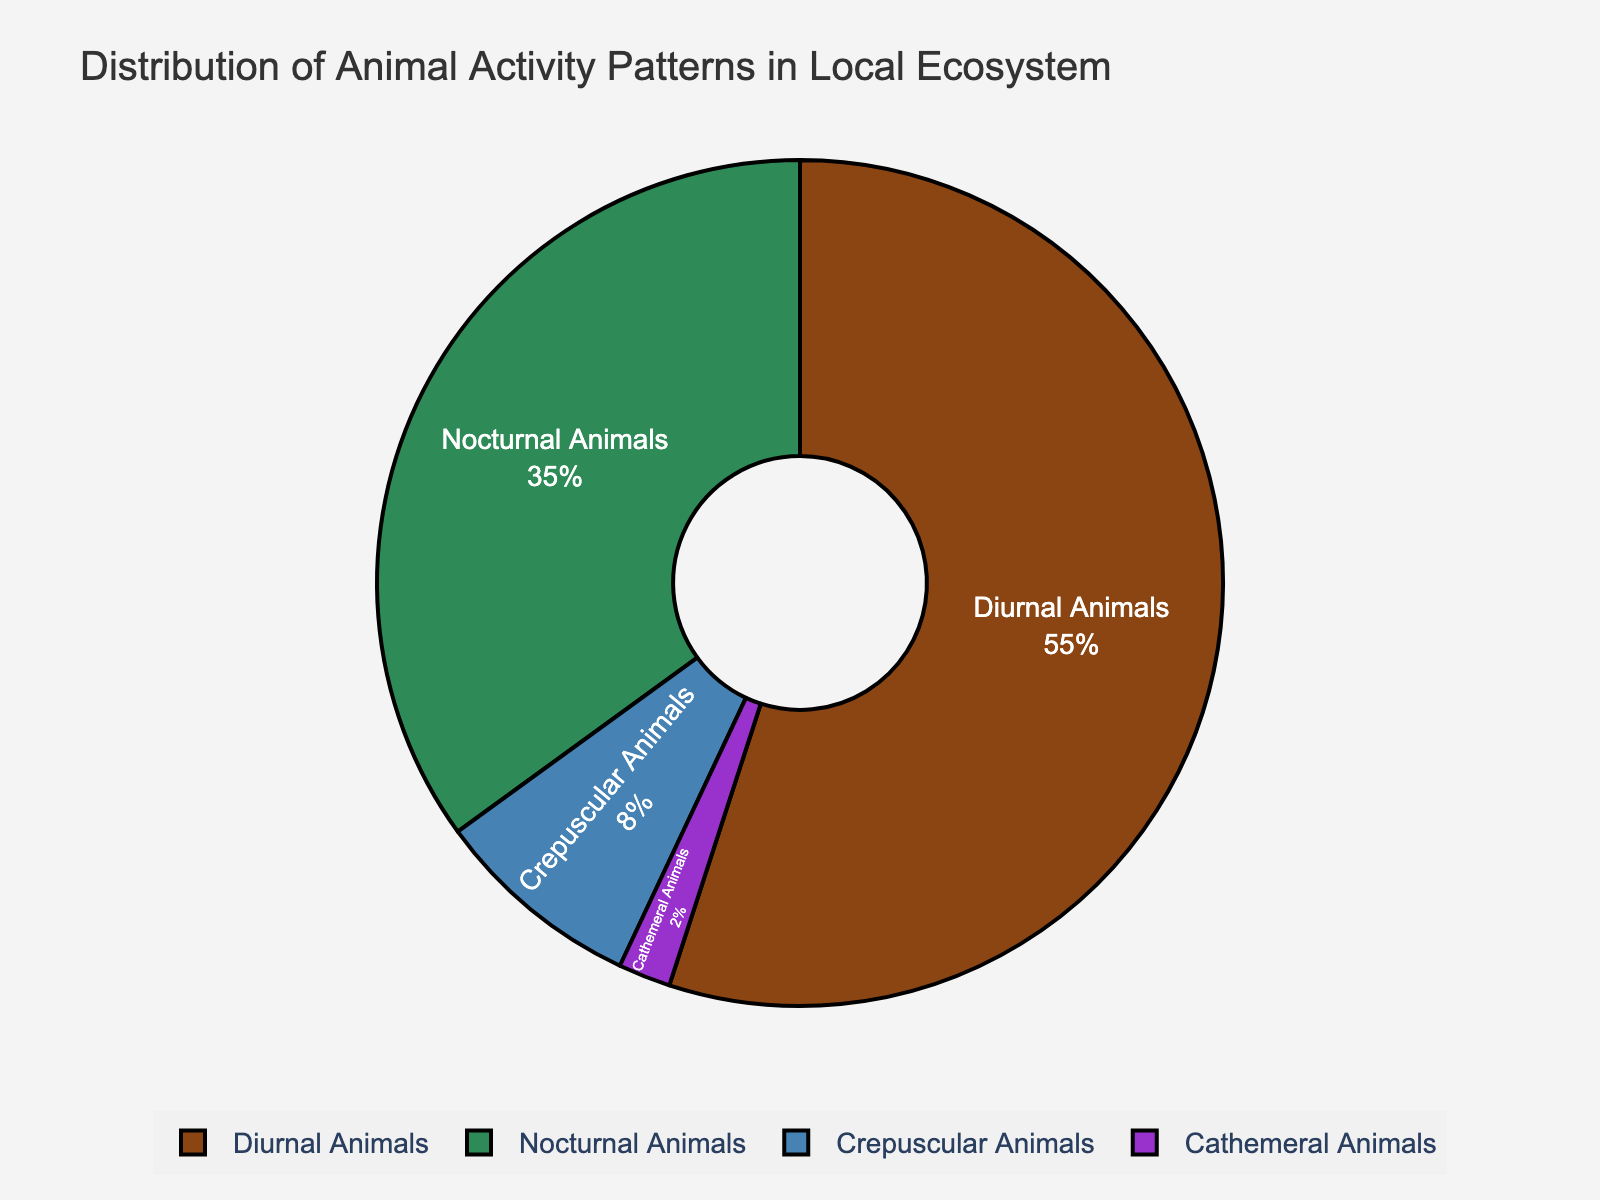What proportion of animals in the local ecosystem are active at twilight? According to the legend, the "Crepuscular Animals" category represents 8% of the overall proportion. Therefore, 8% of animals in the local ecosystem are active during twilight.
Answer: 8% Which category has the highest proportion of animals? By examining the pie chart, the segment representing "Diurnal Animals" is the largest, accounting for 55% of the total proportion, which is the highest.
Answer: Diurnal Animals Are there more nocturnal or crepuscular animals in the local ecosystem? Comparing the two segments visually, "Nocturnal Animals" accounts for 35% while "Crepuscular Animals" accounts for 8%. Therefore, there are more nocturnal animals.
Answer: Nocturnal Animals What is the combined proportion of nocturnal and cathemeral animals? The pie chart shows "Nocturnal Animals" at 35% and "Cathemeral Animals" at 2%. Adding these together, the total combined proportion is 35% + 2% = 37%.
Answer: 37% Which group has a higher proportion: diurnal animals or the combined total of crepuscular and cathemeral animals? "Diurnal Animals" represent 55%. Adding the percentages for "Crepuscular Animals" (8%) and "Cathemeral Animals" (2%) gives 8% + 2% = 10%. 55% is greater than 10%, so diurnal animals have a higher proportion.
Answer: Diurnal Animals What is the ratio of diurnal animals to nocturnal animals? The pie chart shows that diurnal animals make up 55% and nocturnal animals make up 35%. The ratio of diurnal to nocturnal animals is 55:35, which simplifies to 11:7.
Answer: 11:7 How much greater is the proportion of diurnal animals compared to cathemeral animals? "Diurnal Animals" account for 55%, while "Cathemeral Animals" account for 2%. Subtracting these values gives 55% - 2% = 53%, so the proportion of diurnal animals is 53% greater.
Answer: 53% If the proportion of diurnal and nocturnal animals swapped, what would the pie chart look like? Right now, diurnal animals are 55% and nocturnal animals are 35%. If they swapped, diurnal animals would be 35% and nocturnal animals would be 55%. The other proportions remain the same, with crepuscular at 8% and cathemeral at 2%.
Answer: Diurnal: 35%, Nocturnal: 55%, Crepuscular: 8%, Cathemeral: 2% 